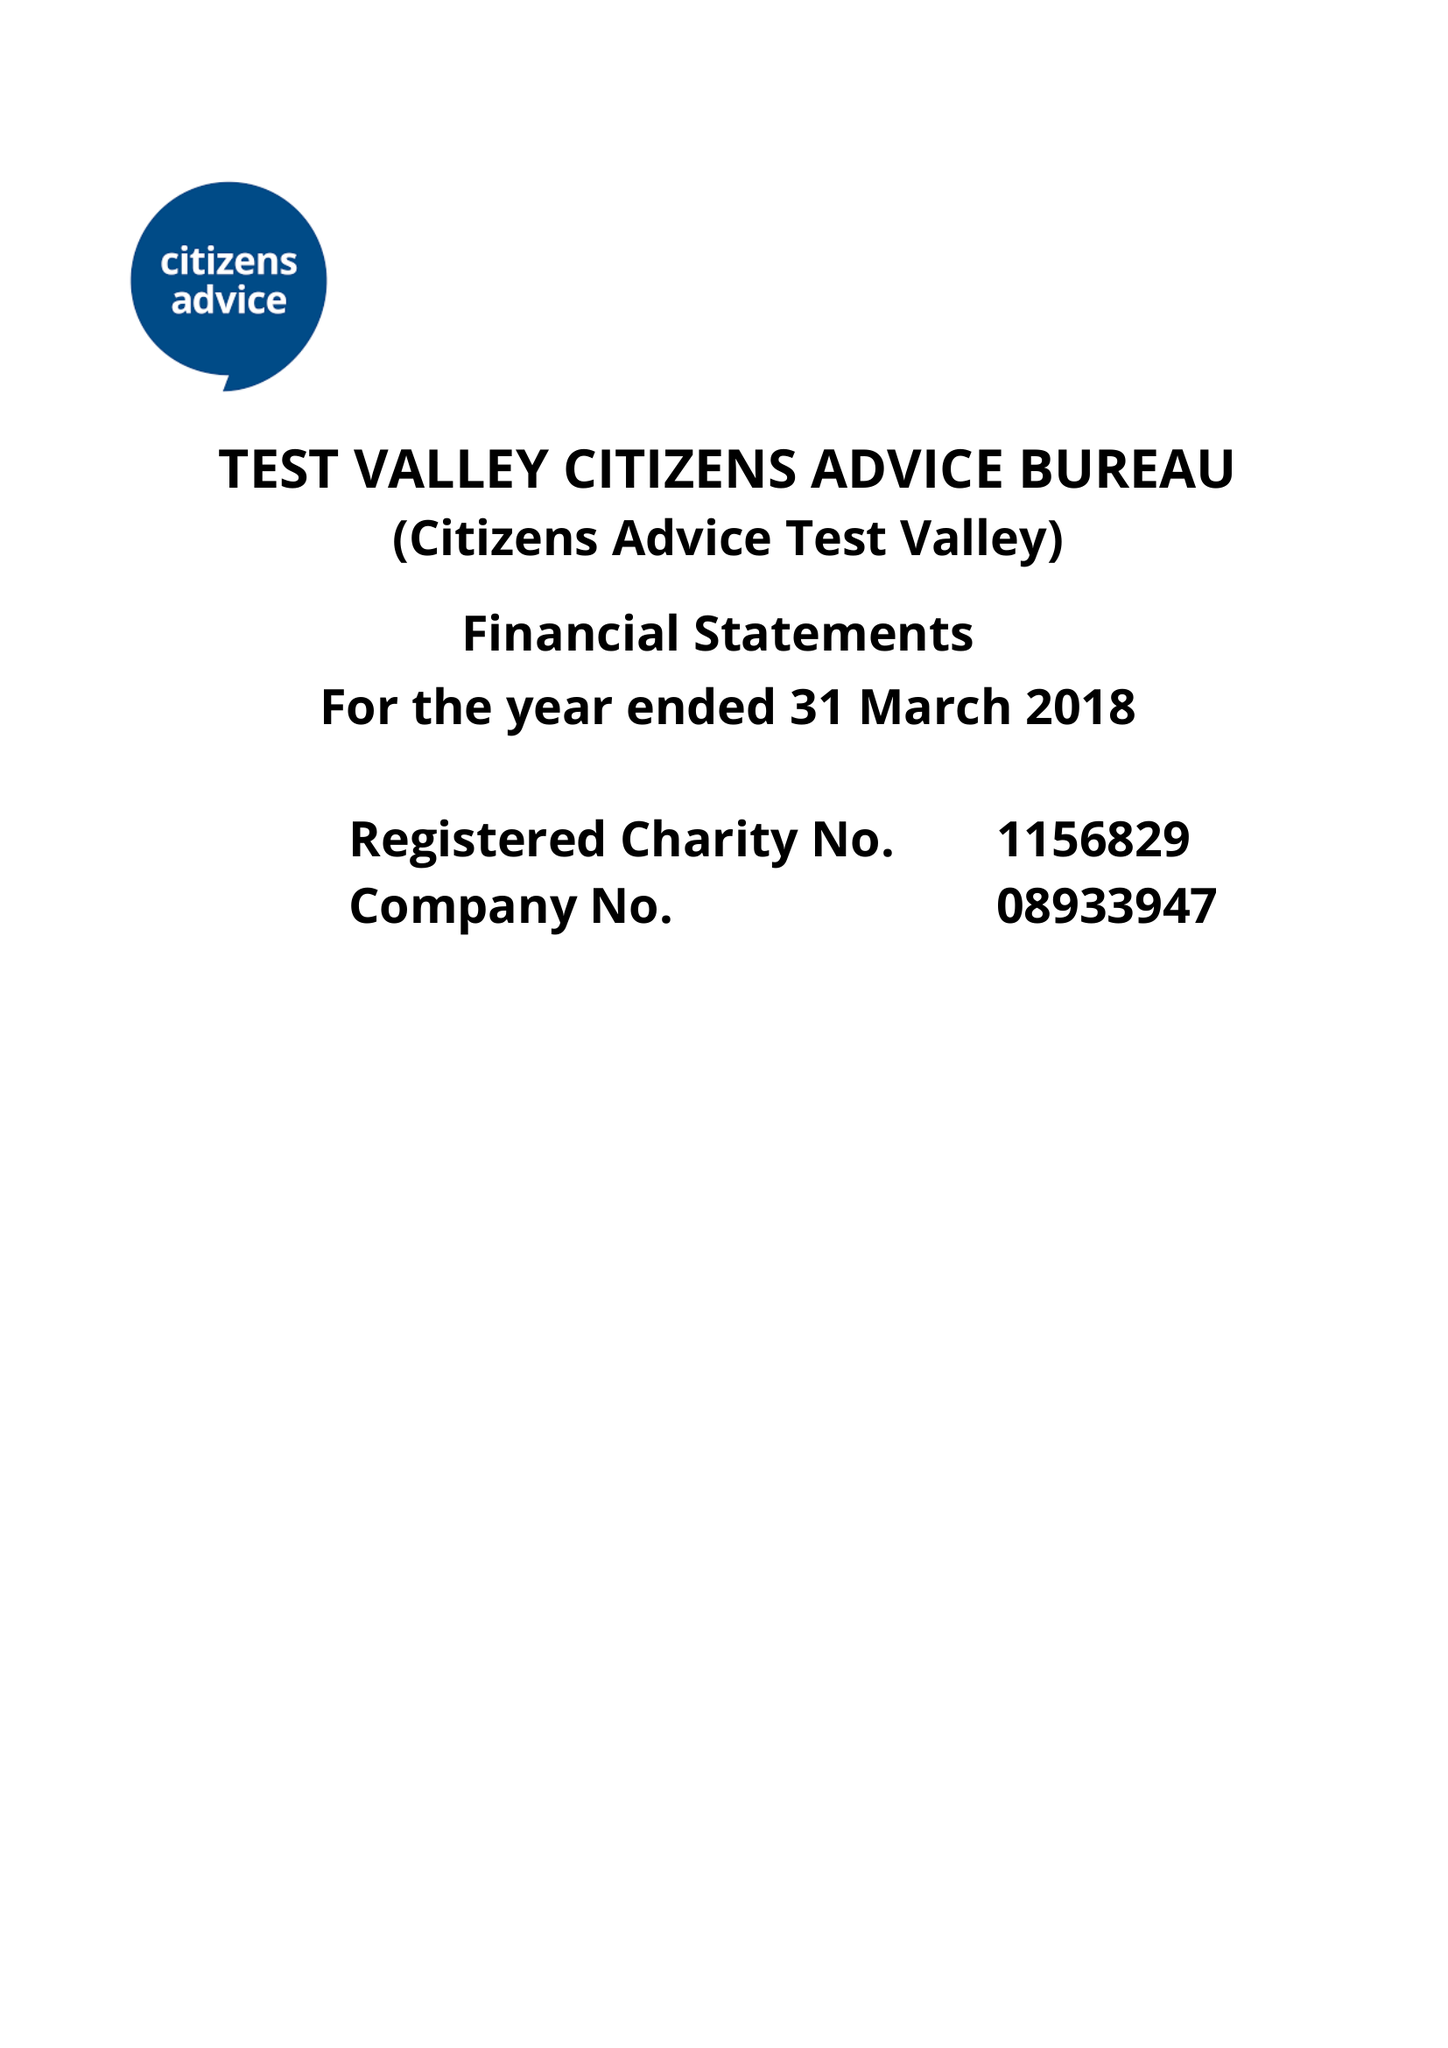What is the value for the income_annually_in_british_pounds?
Answer the question using a single word or phrase. 293596.00 